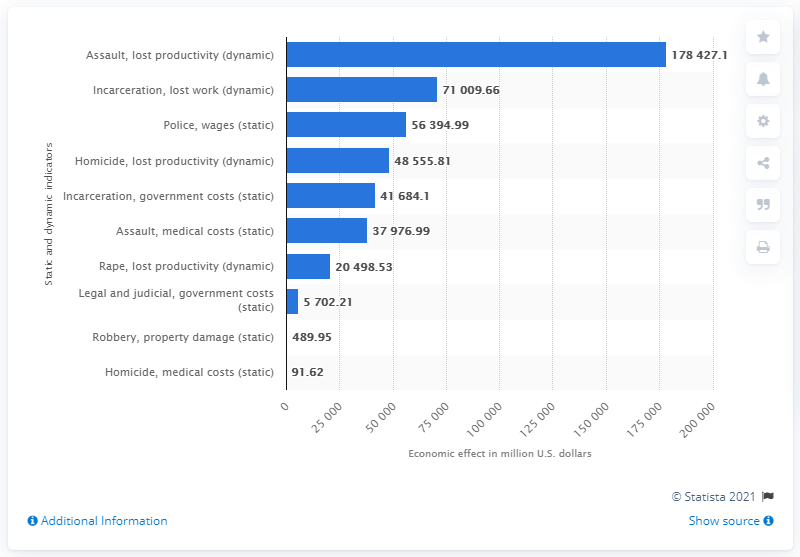Draw attention to some important aspects in this diagram. The economic impact of incarceration cost the U.S. economy a significant amount in lost productivity, with a total of 71009.66 thousand dollars. 